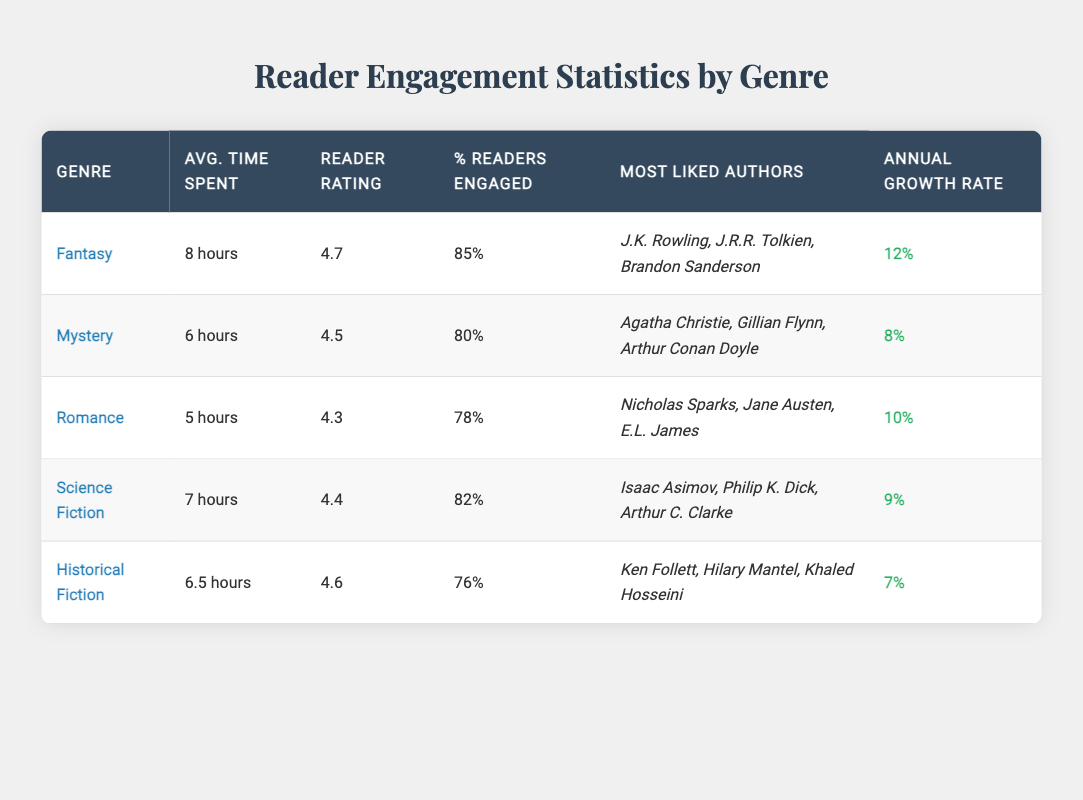What is the average time spent reading Fantasy novels? The table shows that the average time spent per read for the Fantasy genre is specified as "8 hours." Thus, the answer is directly retrieved from the table.
Answer: 8 hours Which genre has the highest reader rating? From the table, we see that the Fantasy genre has the highest reader rating at 4.7, compared to other genres. Therefore, the answer is based on the comparison of the reader ratings listed.
Answer: Fantasy What is the percentage of readers engaged for Romance novels? The table indicates that for the Romance genre, the percentage of readers engaged is 78%. This is directly taken from the relevant row in the table.
Answer: 78% How many more hours do readers spend on average in Fantasy than in Mystery? The average time spent reading Fantasy is 8 hours and for Mystery, it is 6 hours. The difference between these two values is calculated as 8 - 6 = 2 hours. This requires subtraction of the two average times.
Answer: 2 hours Is the annual growth rate for Science Fiction higher than that for Historical Fiction? The annual growth rate for Science Fiction is 9% while for Historical Fiction it is 7%. Since 9% is greater than 7%, we conclude that this statement is true.
Answer: Yes What is the average reader engagement percentage across all genres listed? First, we gather the engagement percentages: 85, 80, 78, 82, and 76. Then, we sum these values: 85 + 80 + 78 + 82 + 76 = 401. To find the average, we divide by the total number of genres (5): 401 / 5 = 80.2%. Therefore, the average engagement percentage is calculated through summation and division.
Answer: 80.2% Which genre had the lowest annual growth rate? The table lists the annual growth rates: 12% for Fantasy, 8% for Mystery, 10% for Romance, 9% for Science Fiction, and 7% for Historical Fiction. Comparing these values, we see that 7% is the lowest value. Hence, this information is derived from comparing the annual growth rates across all genres.
Answer: Historical Fiction Do Romance novels have a higher average time spent per read compared to Historical Fiction? The average time for Romance is 5 hours and for Historical Fiction it is 6.5 hours. Since 5 hours is less than 6.5 hours, the statement is false. This conclusion comes from the comparison of the two average times.
Answer: No What is the total number of author names listed for the Fantasy genre? For the Fantasy genre, the table lists three authors: J.K. Rowling, J.R.R. Tolkien, and Brandon Sanderson. Therefore, we count the author names provided for this genre to answer this question directly.
Answer: 3 Which two genres have a reader rating of 4.5 or higher? The genres with reader ratings of 4.5 or higher are Fantasy (4.7), Mystery (4.5), and Historical Fiction (4.6). Thus, by filtering the ratings and gathering the genres that meet the criterion, the answer is achieved through logical reasoning from the data provided.
Answer: Fantasy, Mystery, Historical Fiction 